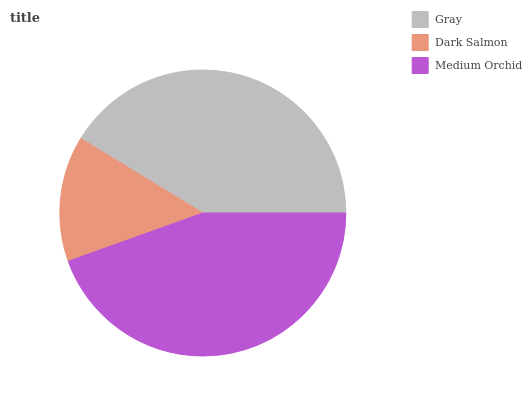Is Dark Salmon the minimum?
Answer yes or no. Yes. Is Medium Orchid the maximum?
Answer yes or no. Yes. Is Medium Orchid the minimum?
Answer yes or no. No. Is Dark Salmon the maximum?
Answer yes or no. No. Is Medium Orchid greater than Dark Salmon?
Answer yes or no. Yes. Is Dark Salmon less than Medium Orchid?
Answer yes or no. Yes. Is Dark Salmon greater than Medium Orchid?
Answer yes or no. No. Is Medium Orchid less than Dark Salmon?
Answer yes or no. No. Is Gray the high median?
Answer yes or no. Yes. Is Gray the low median?
Answer yes or no. Yes. Is Medium Orchid the high median?
Answer yes or no. No. Is Dark Salmon the low median?
Answer yes or no. No. 